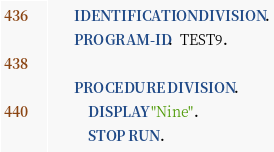Convert code to text. <code><loc_0><loc_0><loc_500><loc_500><_COBOL_>       IDENTIFICATION DIVISION.
       PROGRAM-ID.  TEST9.

       PROCEDURE DIVISION.
           DISPLAY "Nine".
           STOP RUN.</code> 